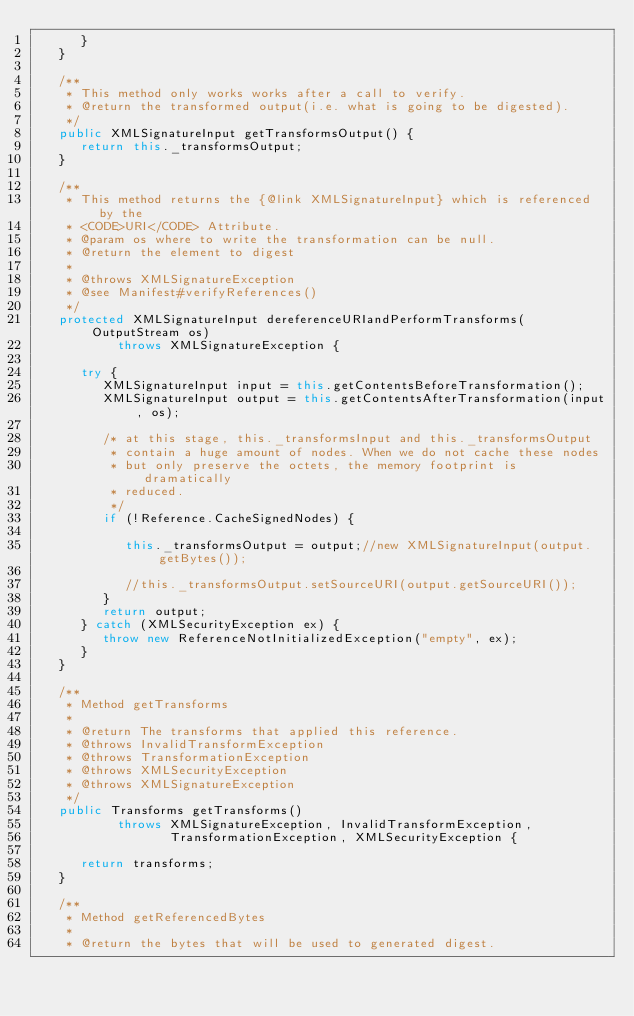Convert code to text. <code><loc_0><loc_0><loc_500><loc_500><_Java_>      }
   }

   /**
    * This method only works works after a call to verify.
    * @return the transformed output(i.e. what is going to be digested).
    */
   public XMLSignatureInput getTransformsOutput() {
      return this._transformsOutput;
   }

   /**
    * This method returns the {@link XMLSignatureInput} which is referenced by the
    * <CODE>URI</CODE> Attribute.
    * @param os where to write the transformation can be null.
    * @return the element to digest
    *
    * @throws XMLSignatureException
    * @see Manifest#verifyReferences()
    */
   protected XMLSignatureInput dereferenceURIandPerformTransforms(OutputStream os)
           throws XMLSignatureException {

      try {
         XMLSignatureInput input = this.getContentsBeforeTransformation();
         XMLSignatureInput output = this.getContentsAfterTransformation(input, os);

         /* at this stage, this._transformsInput and this._transformsOutput
          * contain a huge amount of nodes. When we do not cache these nodes
          * but only preserve the octets, the memory footprint is dramatically
          * reduced.
          */
         if (!Reference.CacheSignedNodes) {

            this._transformsOutput = output;//new XMLSignatureInput(output.getBytes());

            //this._transformsOutput.setSourceURI(output.getSourceURI());
         }
         return output;
      } catch (XMLSecurityException ex) {
         throw new ReferenceNotInitializedException("empty", ex);
      }
   }

   /**
    * Method getTransforms
    *
    * @return The transforms that applied this reference.
    * @throws InvalidTransformException
    * @throws TransformationException
    * @throws XMLSecurityException
    * @throws XMLSignatureException
    */
   public Transforms getTransforms()
           throws XMLSignatureException, InvalidTransformException,
                  TransformationException, XMLSecurityException {

      return transforms;
   }

   /**
    * Method getReferencedBytes
    *
    * @return the bytes that will be used to generated digest.</code> 